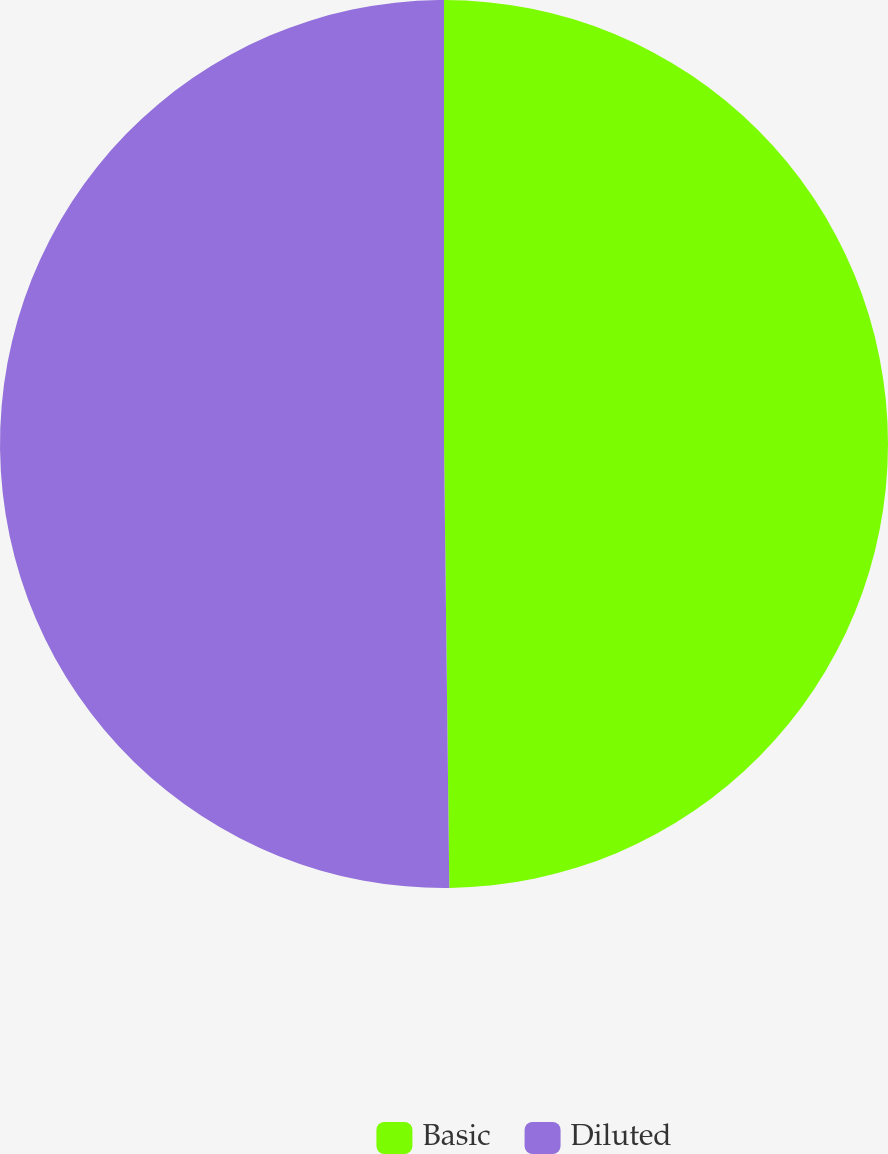Convert chart to OTSL. <chart><loc_0><loc_0><loc_500><loc_500><pie_chart><fcel>Basic<fcel>Diluted<nl><fcel>49.81%<fcel>50.19%<nl></chart> 